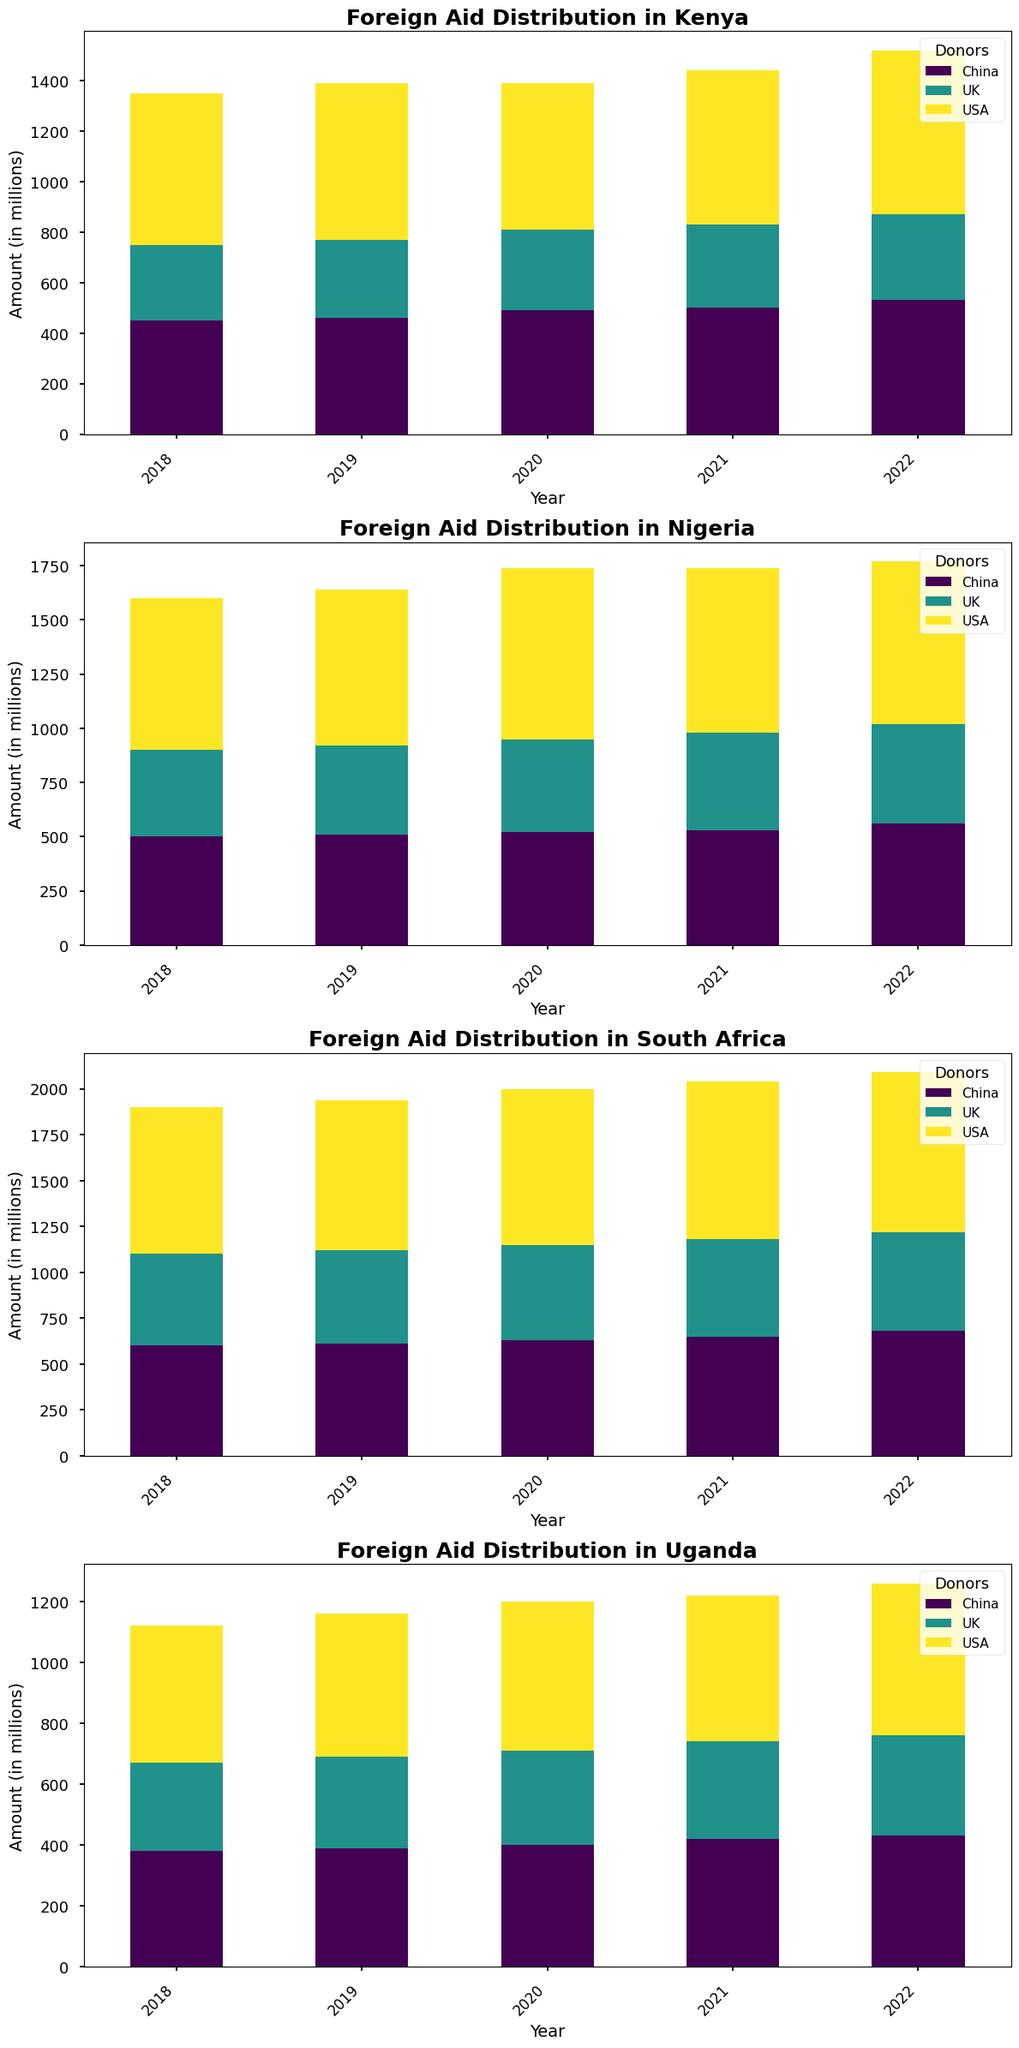How does the total foreign aid received by Kenya in 2020 compare to that of Uganda in the same year? To compare, sum all the aid amounts received by Kenya in 2020 from USA, China, and UK (580 + 490 + 320 = 1390). Do the same for Uganda (490 + 400 + 310 = 1200). Kenya received 190 million more than Uganda in 2020.
Answer: Kenya received 190 million more Which donor country provided the most aid to South Africa in 2019? Check the heights of the bars for South Africa in 2019. The tallest bar corresponds to USA, providing the highest aid (820 million).
Answer: USA What is the average annual aid received by Nigeria from China over the 5-year period? Sum the aid amounts received by Nigeria from China over the 5 years (500 + 510 + 520 + 530 + 560 = 2620). Then, divide by 5 (2620/5 = 524).
Answer: 524 million Was the aid received from the UK increasing or decreasing for Uganda over the last 5 years? Examine the height of the bars for Uganda from the UK over the years (290 in 2018, 300 in 2019, 310 in 2020, 320 in 2021, and 330 in 2022). The bars show an increasing trend each year.
Answer: Increasing Which country received the least aid from any donor in 2022, and what was the amount? For 2022, examine the shortest bars across all countries and donors. Uganda received the least from the UK (330 million).
Answer: Uganda, 330 million Did Nigeria receive more aid from the USA or the UK in 2021? Compare the heights of the bars for Nigeria in 2021. The USA's bar (760 million) is taller than the UK's bar (450 million).
Answer: USA What is the total aid received by South Africa from all donors in 2022? Sum the aid amounts received by South Africa from USA, China, and UK in 2022 (870 + 680 + 540 = 2090).
Answer: 2090 million Which donor's aid contribution to Kenya has shown the highest increase from 2018 to 2022? Calculate the difference between 2022 and 2018 amounts for each donor to Kenya: USA (650 - 600 = 50), China (530 - 450 = 80), and UK (340 - 300 = 40). The highest increase is from China with 80 million.
Answer: China What is the total aid received by all countries from China in the year 2020? Sum the amounts received by Kenya, Nigeria, Uganda, and South Africa from China in 2020 (490 + 520 + 400 + 630 = 2040).
Answer: 2040 million 